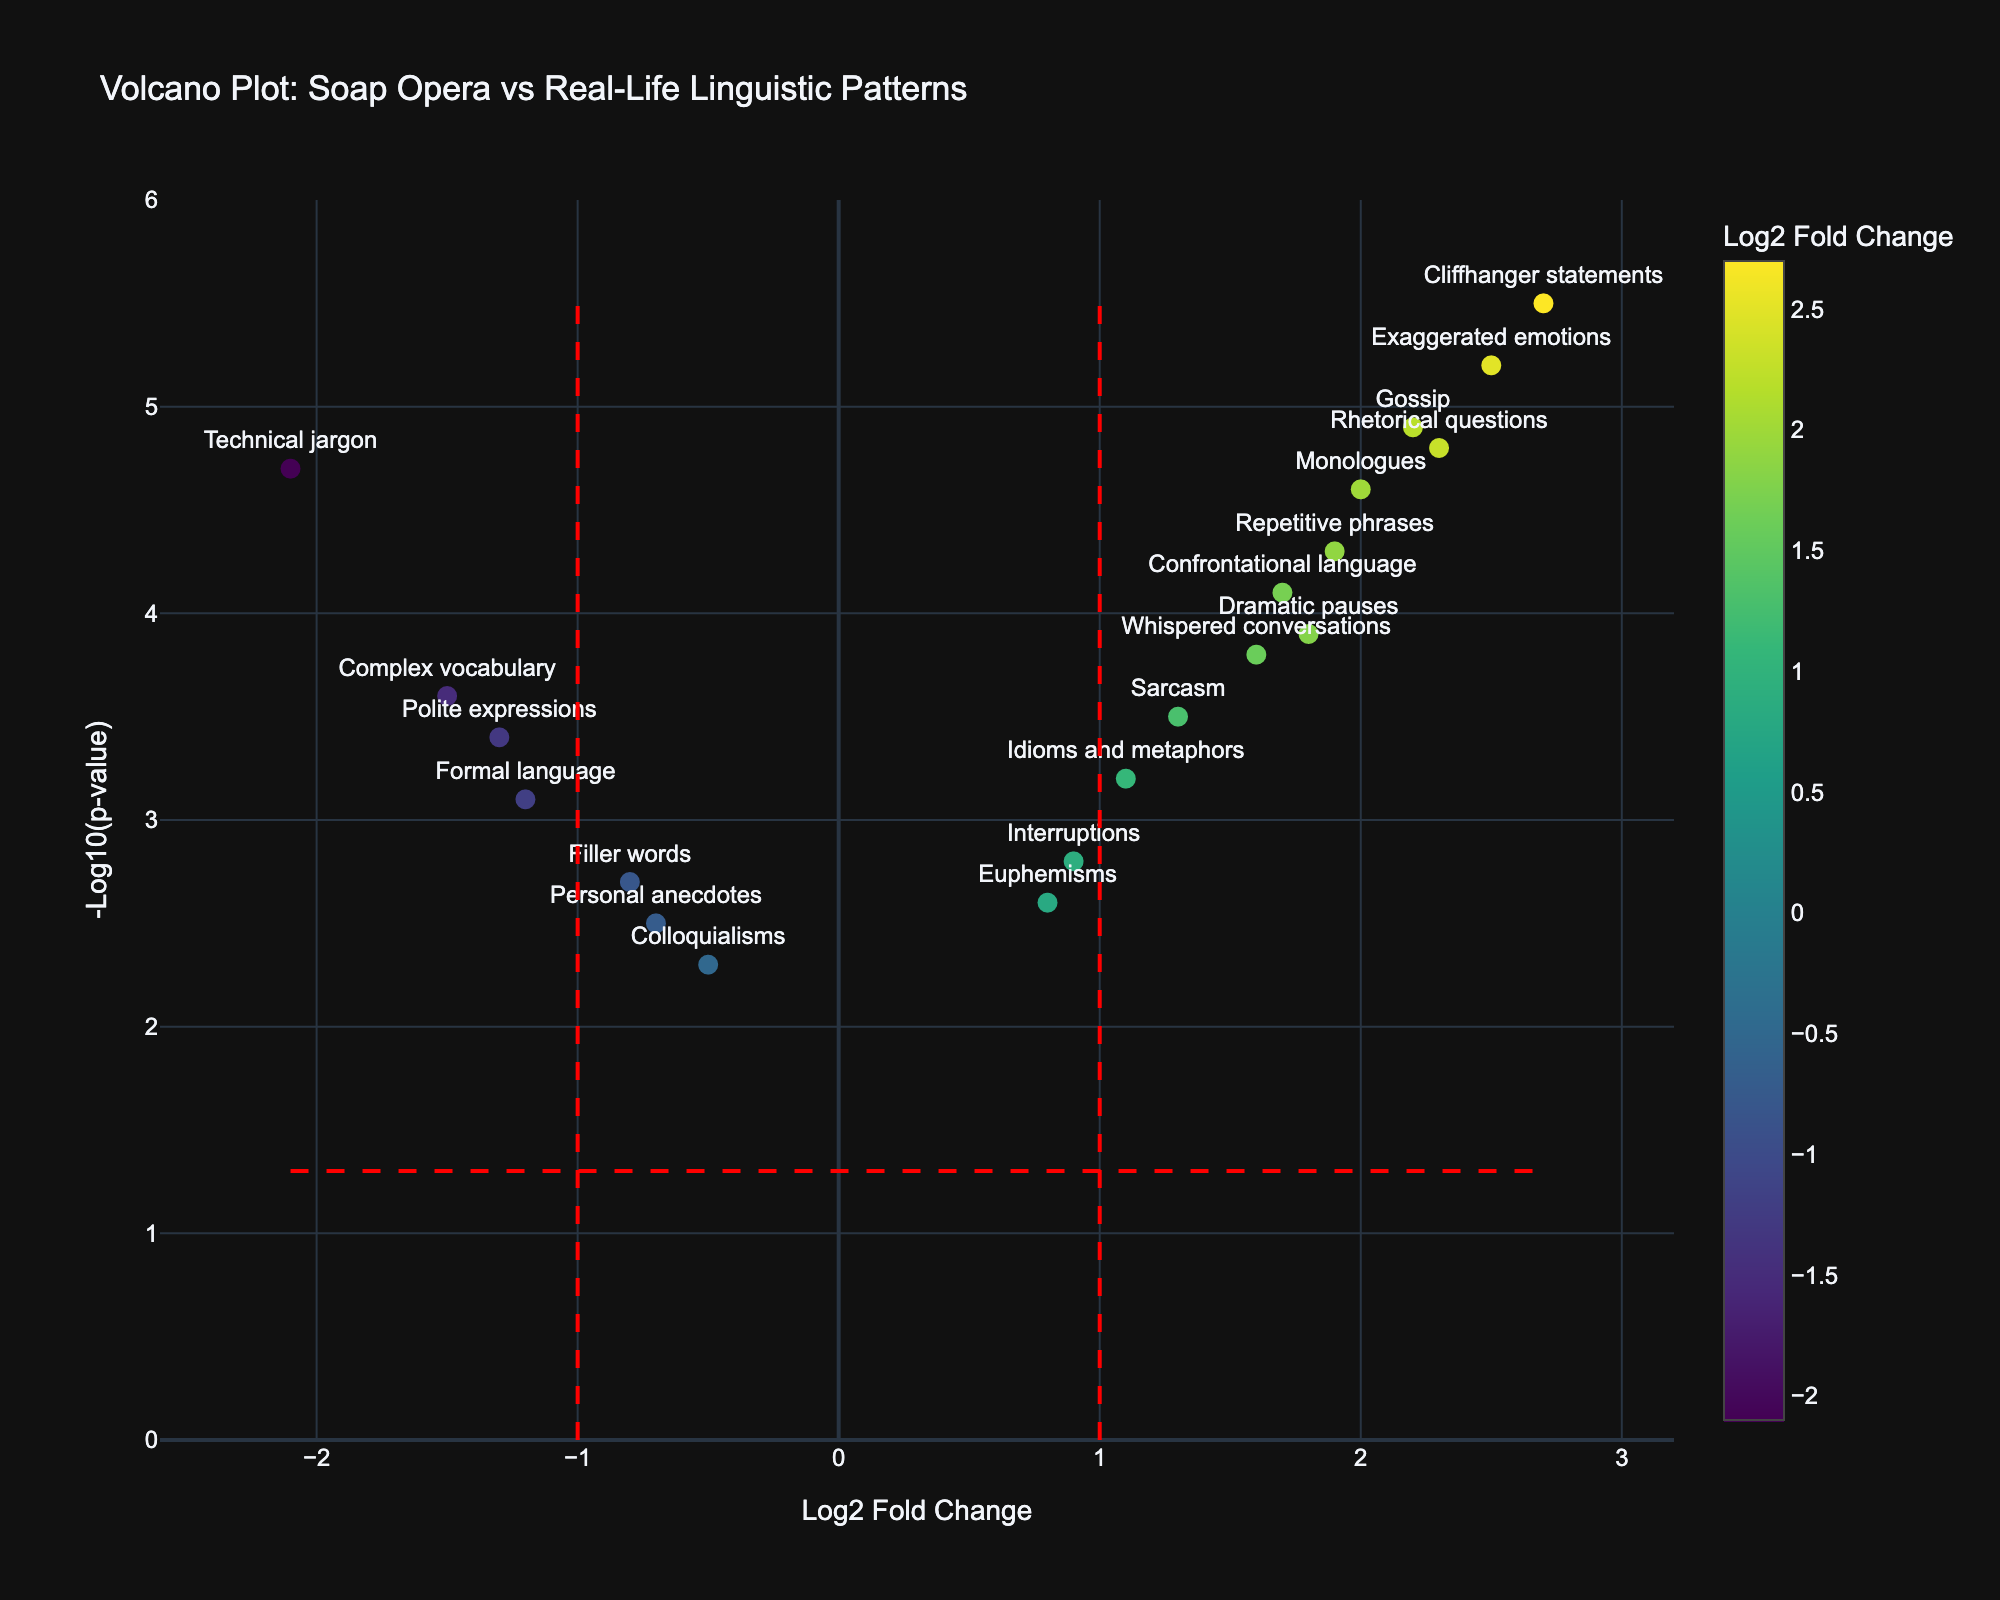What is the title of the plot? The title of the plot is displayed at the top center of the figure. It reads "Volcano Plot: Soap Opera vs Real-Life Linguistic Patterns"
Answer: Volcano Plot: Soap Opera vs Real-Life Linguistic Patterns How many language features have Log2 Fold Change values greater than 2? By looking at the x-axis, we can count the number of data points (features) that are plotted to the right of the 2 mark. These are: "Exaggerated emotions," "Cliffhanger statements," and "Rhetorical questions."
Answer: 3 Which language feature has the highest -Log10(p-value)? The y-axis represents the -Log10(p-value). The highest point on this axis corresponds to "Cliffhanger statements."
Answer: Cliffhanger statements What is the Log2 Fold Change of filler words? Find "Filler words" in the plot and look at the corresponding x-axis value, which is -0.8.
Answer: -0.8 Are technical jargons overrepresented or underrepresented in soap opera dialogues? Look at the Log2 Fold Change value for "Technical jargon." It is negative (-2.1), indicating that it is underrepresented in soap opera dialogues.
Answer: Underrepresented Which language feature is least significant in terms of -Log10(p-value)? The feature closest to the bottom of the y-axis has the lowest -Log10(p-value). This is "Colloquialisms."
Answer: Colloquialisms Compare the Log2 Fold Change between "Repetitive phrases" and "Complex vocabulary." Which one is higher, and by how much? "Repetitive phrases" has a Log2 Fold Change of 1.9, and "Complex vocabulary" has -1.5. The difference is 1.9 - (-1.5) = 3.4.
Answer: Repetitive phrases, by 3.4 Which language features are highlighted as significant in the plot? The significant features are those above the horizontal red dashed line indicating the p-value threshold, often with higher
Answer: "Rhetorical questions," "Exaggerated emotions," "Gossip," "Cliffhanger statements," "Monologues," and "Technical jargon" have higher -Log10(p-value) How many features have both negative Log2 Fold Change and a -Log10(p-value) above 4? Count the points on the left side of 0 (negative Log2 Fold Change) that are above 4 on the y-axis. "Technical jargon" and "Formal language" fit this criterion.
Answer: 2 What does the red dashed vertical line at Log2FoldChange = 1 represent? The red dashed vertical line at Log2FoldChange = 1 helps to visually indicate overrepresented features where the log2 fold change > 1. Similarly, the left line at -1 indicates underrepresented features where the log2 fold change < -1.
Answer: Overrepresented feature boundary 